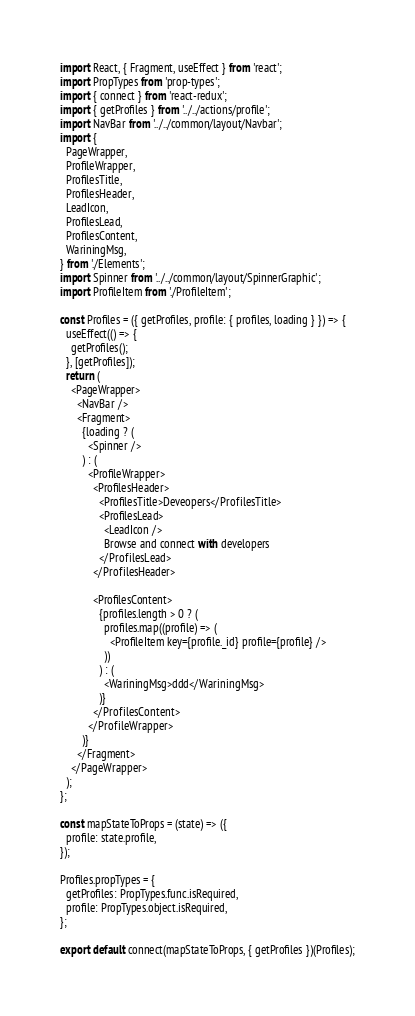<code> <loc_0><loc_0><loc_500><loc_500><_JavaScript_>import React, { Fragment, useEffect } from 'react';
import PropTypes from 'prop-types';
import { connect } from 'react-redux';
import { getProfiles } from '../../actions/profile';
import NavBar from '../../common/layout/Navbar';
import {
  PageWrapper,
  ProfileWrapper,
  ProfilesTitle,
  ProfilesHeader,
  LeadIcon,
  ProfilesLead,
  ProfilesContent,
  WariningMsg,
} from './Elements';
import Spinner from '../../common/layout/SpinnerGraphic';
import ProfileItem from './ProfileItem';

const Profiles = ({ getProfiles, profile: { profiles, loading } }) => {
  useEffect(() => {
    getProfiles();
  }, [getProfiles]);
  return (
    <PageWrapper>
      <NavBar />
      <Fragment>
        {loading ? (
          <Spinner />
        ) : (
          <ProfileWrapper>
            <ProfilesHeader>
              <ProfilesTitle>Deveopers</ProfilesTitle>
              <ProfilesLead>
                <LeadIcon />
                Browse and connect with developers
              </ProfilesLead>
            </ProfilesHeader>

            <ProfilesContent>
              {profiles.length > 0 ? (
                profiles.map((profile) => (
                  <ProfileItem key={profile._id} profile={profile} />
                ))
              ) : (
                <WariningMsg>ddd</WariningMsg>
              )}
            </ProfilesContent>
          </ProfileWrapper>
        )}
      </Fragment>
    </PageWrapper>
  );
};

const mapStateToProps = (state) => ({
  profile: state.profile,
});

Profiles.propTypes = {
  getProfiles: PropTypes.func.isRequired,
  profile: PropTypes.object.isRequired,
};

export default connect(mapStateToProps, { getProfiles })(Profiles);
</code> 